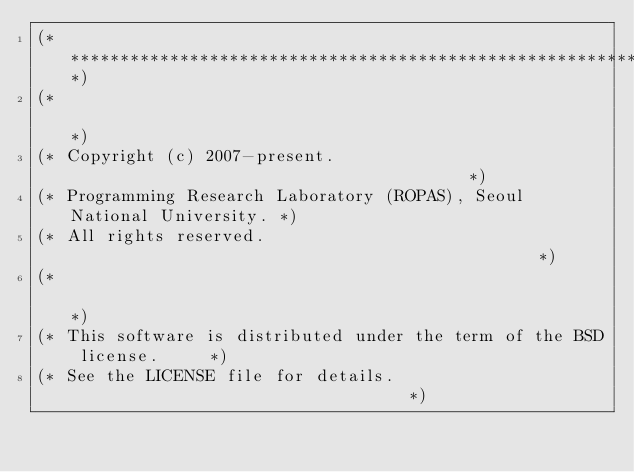<code> <loc_0><loc_0><loc_500><loc_500><_OCaml_>(***********************************************************************)
(*                                                                     *)
(* Copyright (c) 2007-present.                                         *)
(* Programming Research Laboratory (ROPAS), Seoul National University. *)
(* All rights reserved.                                                *)
(*                                                                     *)
(* This software is distributed under the term of the BSD license.     *)
(* See the LICENSE file for details.                                   *)</code> 